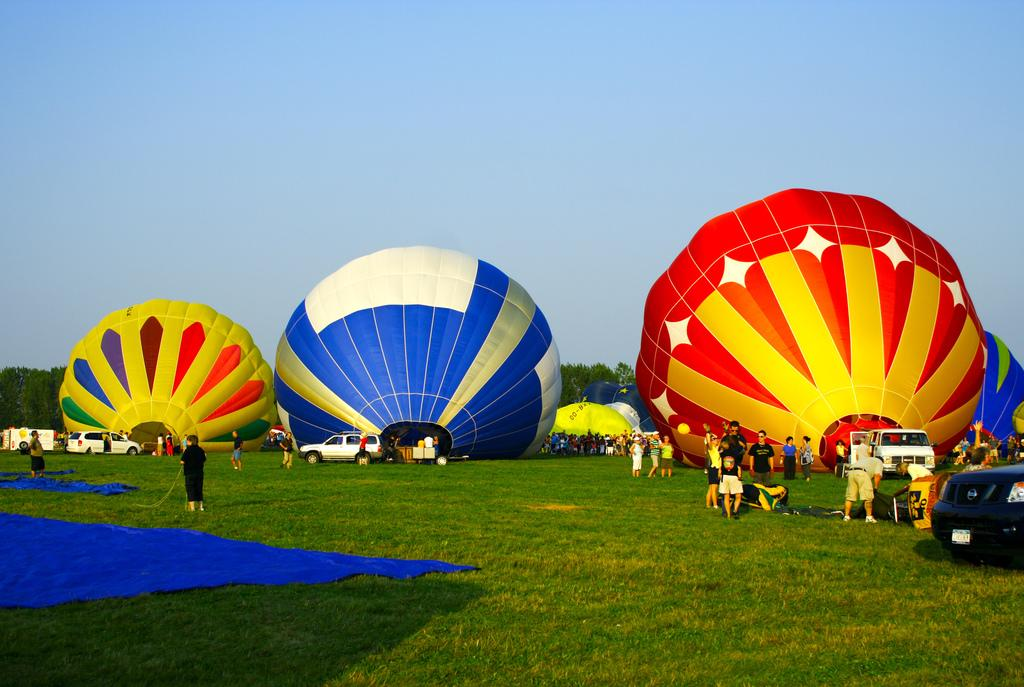What type of surface is on the ground in the image? There is grass on the ground in the image. What color is the sheet visible in the image? There is a blue color sheet in the image. How many people can be seen in the image? There are many people in the image. What decorative items are present in the image? There are balloons in the image. What can be seen in the background of the image? The sky and trees are visible in the background of the image. What type of sticks are being used to stir the sugar in the image? There is no sugar or sticks present in the image. Where is the cemetery located in the image? There is no cemetery present in the image. 